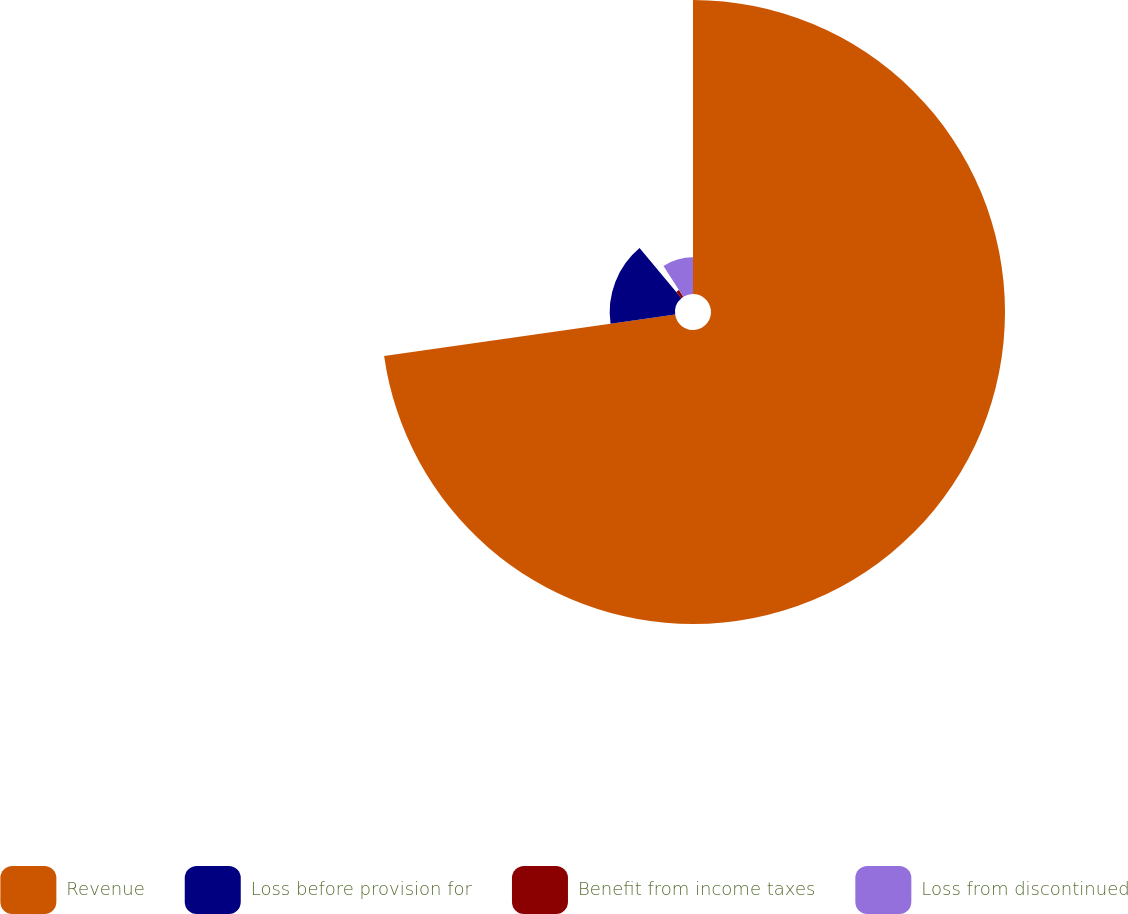Convert chart to OTSL. <chart><loc_0><loc_0><loc_500><loc_500><pie_chart><fcel>Revenue<fcel>Loss before provision for<fcel>Benefit from income taxes<fcel>Loss from discontinued<nl><fcel>72.76%<fcel>16.16%<fcel>2.01%<fcel>9.08%<nl></chart> 